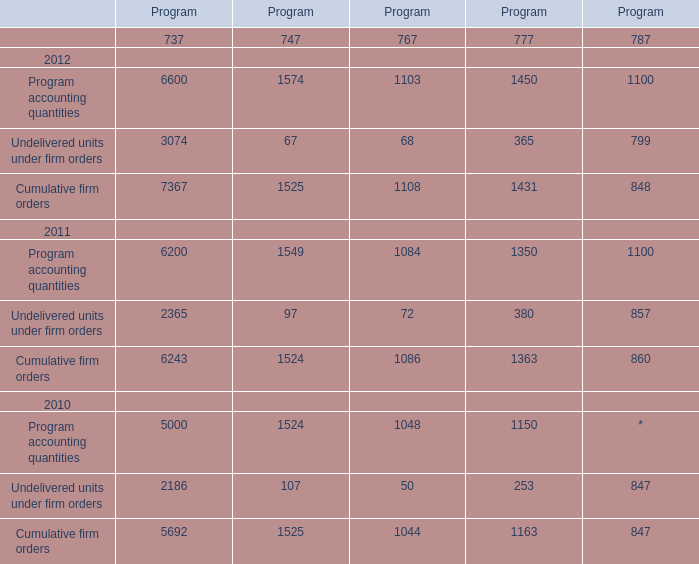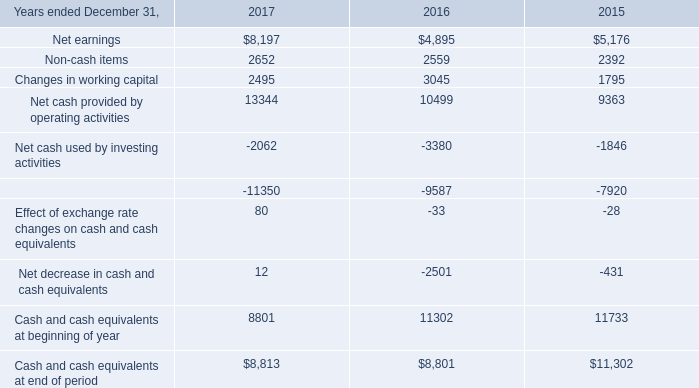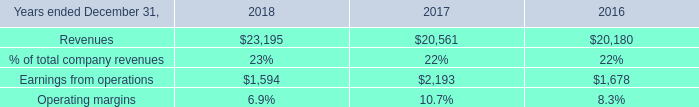If Cumulative firm orders of Program737 develops with the same increasing rate in 2012, what will it reach in 2013? 
Computations: (7367 * (1 + ((7367 - 6243) / 6243)))
Answer: 8693.36681. 